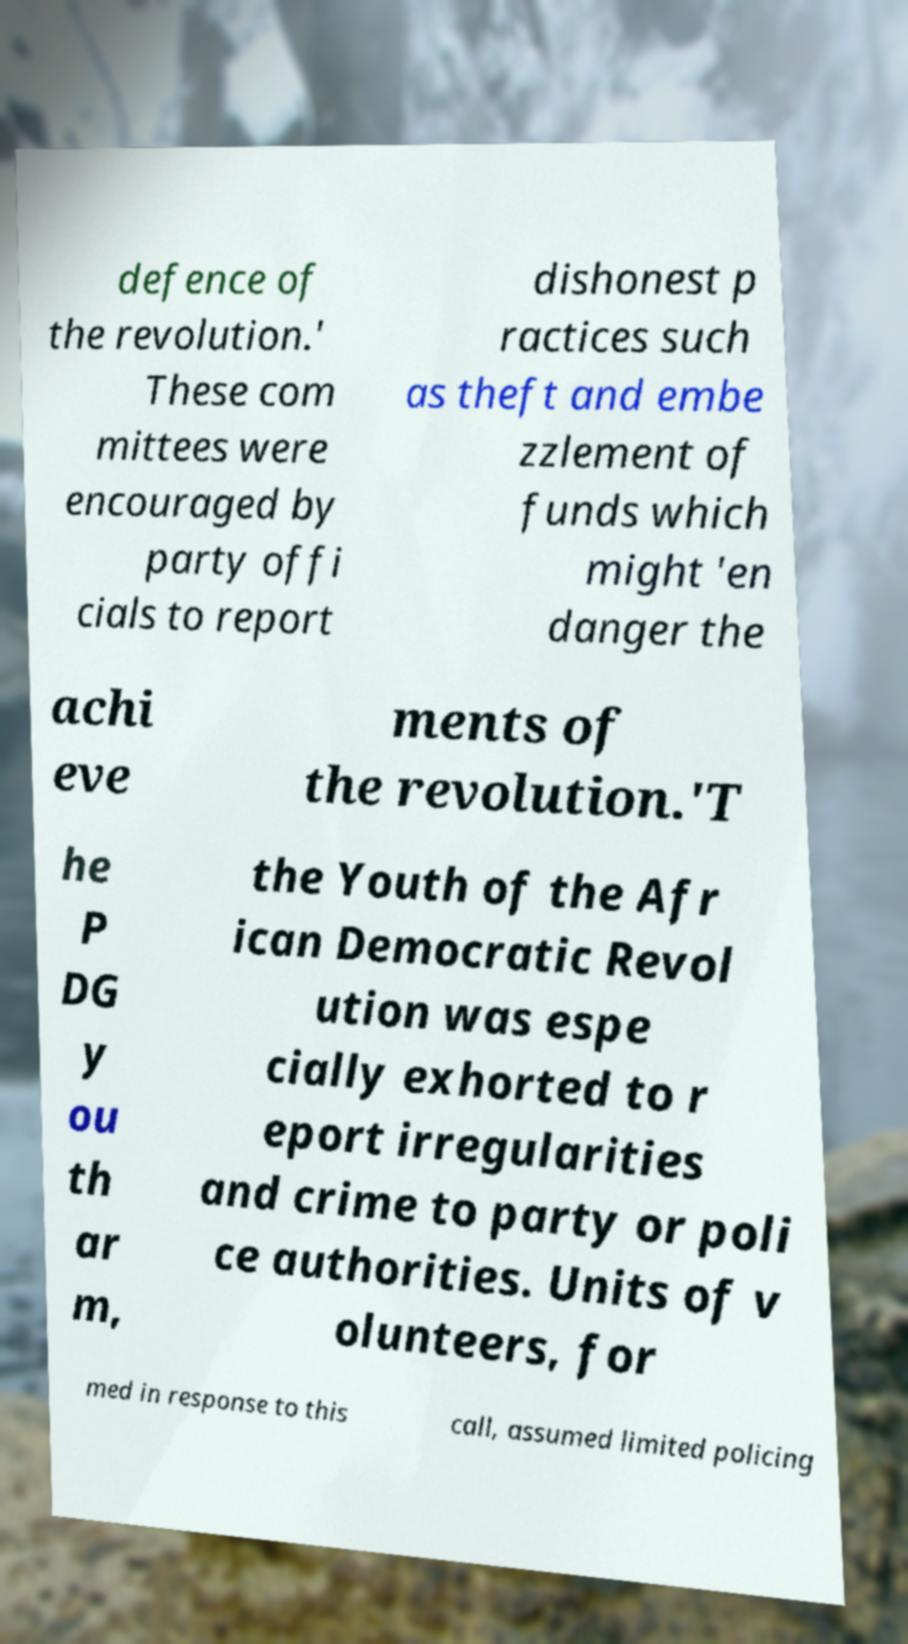Can you accurately transcribe the text from the provided image for me? defence of the revolution.' These com mittees were encouraged by party offi cials to report dishonest p ractices such as theft and embe zzlement of funds which might 'en danger the achi eve ments of the revolution.'T he P DG y ou th ar m, the Youth of the Afr ican Democratic Revol ution was espe cially exhorted to r eport irregularities and crime to party or poli ce authorities. Units of v olunteers, for med in response to this call, assumed limited policing 